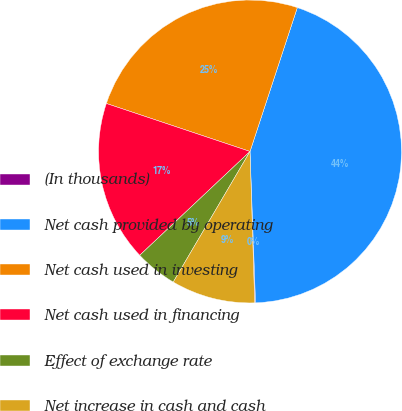<chart> <loc_0><loc_0><loc_500><loc_500><pie_chart><fcel>(In thousands)<fcel>Net cash provided by operating<fcel>Net cash used in investing<fcel>Net cash used in financing<fcel>Effect of exchange rate<fcel>Net increase in cash and cash<nl><fcel>0.09%<fcel>44.36%<fcel>24.92%<fcel>17.15%<fcel>4.52%<fcel>8.95%<nl></chart> 